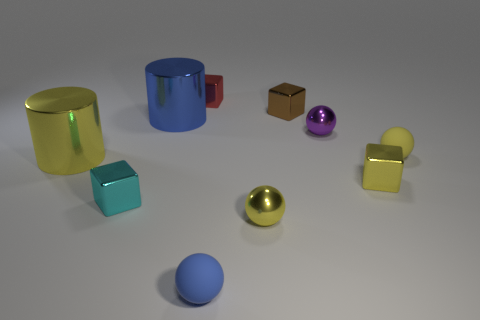Subtract all blue spheres. How many spheres are left? 3 Subtract all gray blocks. How many yellow balls are left? 2 Subtract 1 balls. How many balls are left? 3 Subtract all cylinders. How many objects are left? 8 Subtract all tiny blue matte spheres. Subtract all tiny red shiny objects. How many objects are left? 8 Add 5 cylinders. How many cylinders are left? 7 Add 1 small purple things. How many small purple things exist? 2 Subtract all blue spheres. How many spheres are left? 3 Subtract 0 gray blocks. How many objects are left? 10 Subtract all blue blocks. Subtract all cyan cylinders. How many blocks are left? 4 